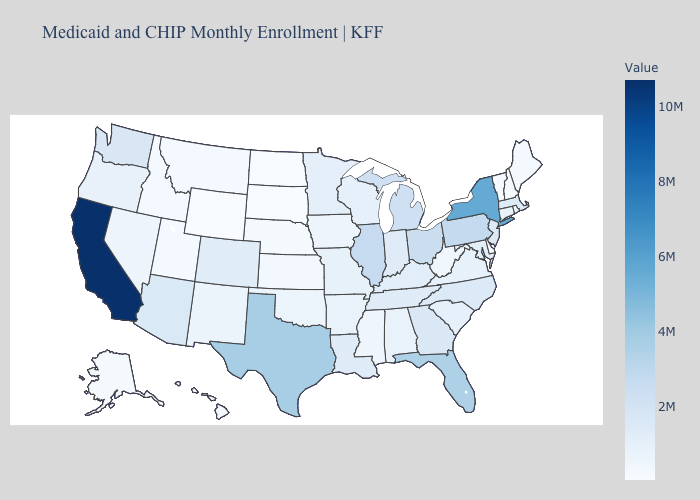Which states have the lowest value in the USA?
Answer briefly. Wyoming. Among the states that border Pennsylvania , does New Jersey have the lowest value?
Keep it brief. No. Does Maine have a lower value than New York?
Short answer required. Yes. 